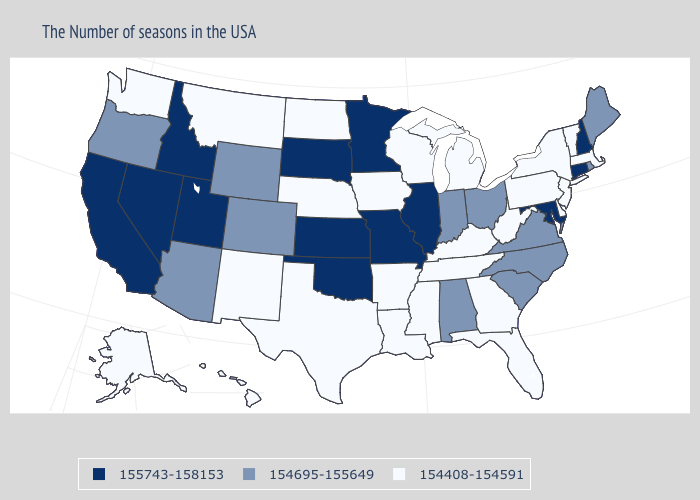Name the states that have a value in the range 155743-158153?
Be succinct. New Hampshire, Connecticut, Maryland, Illinois, Missouri, Minnesota, Kansas, Oklahoma, South Dakota, Utah, Idaho, Nevada, California. Name the states that have a value in the range 155743-158153?
Short answer required. New Hampshire, Connecticut, Maryland, Illinois, Missouri, Minnesota, Kansas, Oklahoma, South Dakota, Utah, Idaho, Nevada, California. Name the states that have a value in the range 154695-155649?
Short answer required. Maine, Rhode Island, Virginia, North Carolina, South Carolina, Ohio, Indiana, Alabama, Wyoming, Colorado, Arizona, Oregon. Name the states that have a value in the range 155743-158153?
Keep it brief. New Hampshire, Connecticut, Maryland, Illinois, Missouri, Minnesota, Kansas, Oklahoma, South Dakota, Utah, Idaho, Nevada, California. Does the map have missing data?
Quick response, please. No. Is the legend a continuous bar?
Keep it brief. No. Does Idaho have the highest value in the West?
Short answer required. Yes. Name the states that have a value in the range 154695-155649?
Keep it brief. Maine, Rhode Island, Virginia, North Carolina, South Carolina, Ohio, Indiana, Alabama, Wyoming, Colorado, Arizona, Oregon. How many symbols are there in the legend?
Concise answer only. 3. What is the value of Vermont?
Concise answer only. 154408-154591. Does the first symbol in the legend represent the smallest category?
Write a very short answer. No. Name the states that have a value in the range 154408-154591?
Answer briefly. Massachusetts, Vermont, New York, New Jersey, Delaware, Pennsylvania, West Virginia, Florida, Georgia, Michigan, Kentucky, Tennessee, Wisconsin, Mississippi, Louisiana, Arkansas, Iowa, Nebraska, Texas, North Dakota, New Mexico, Montana, Washington, Alaska, Hawaii. Name the states that have a value in the range 154695-155649?
Be succinct. Maine, Rhode Island, Virginia, North Carolina, South Carolina, Ohio, Indiana, Alabama, Wyoming, Colorado, Arizona, Oregon. Does the first symbol in the legend represent the smallest category?
Concise answer only. No. 